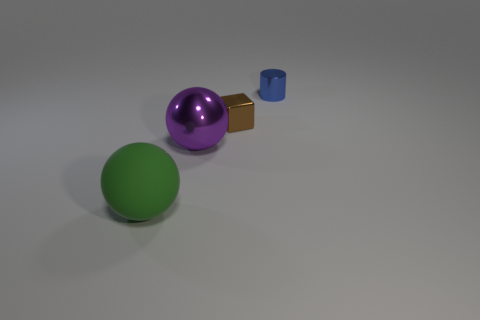Add 3 small blue cylinders. How many objects exist? 7 Subtract all blocks. How many objects are left? 3 Add 4 balls. How many balls exist? 6 Subtract 1 brown blocks. How many objects are left? 3 Subtract all metal objects. Subtract all small blue metallic blocks. How many objects are left? 1 Add 1 big spheres. How many big spheres are left? 3 